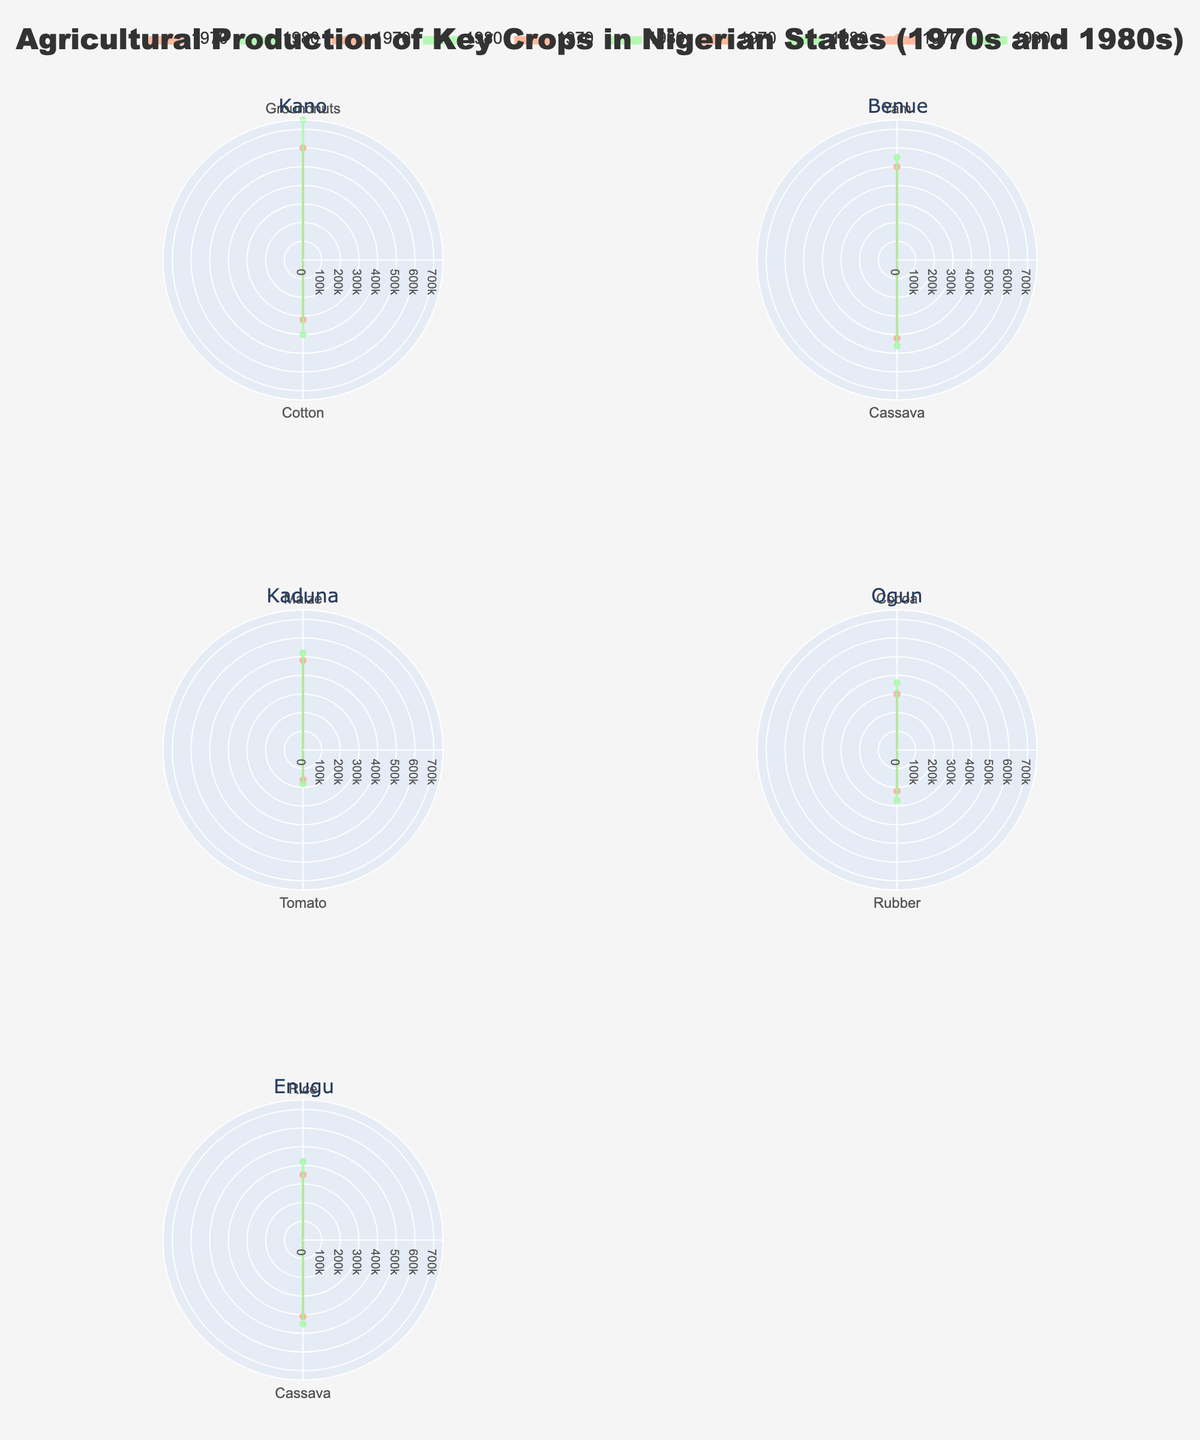How many states are represented in the figure? There are six subplot titles, and each one corresponds to a unique state.
Answer: 6 Which crop had the lowest production in Kano in 1970? In the Kano subplot for 1970, the smallest value on the radial axis corresponds to Cotton with 320,000 metric tons.
Answer: Cotton How did the production of groundnuts in Kano change from 1970 to 1980? In the Kano subplot, the radial value for Groundnuts increased from 600,000 metric tons in 1970 to 750,000 metric tons in 1980.
Answer: Increased Which state had the highest production of Cocoa in the 1980s? Only Ogun produces Cocoa, shown by the largest radial value in its subplot. It increased to 360,000 metric tons in the 1980s.
Answer: Ogun Were there any crops with no change in production between the 1970s and the 1980s? By examining each subplot, we can see that no crops maintained the same radial value between the two time periods; all show changes.
Answer: No Which state's production of Maize was higher in 1980 compared to 1970? In the Kaduna subplot, the production of Maize increased from 480,000 metric tons in 1970 to 520,000 metric tons in 1980.
Answer: Kaduna What is the total production of Yams and Cassava in Benue in 1980? For Benue in 1980, Yam production is 550,000 metric tons and Cassava production is 460,000 metric tons. Adding these values gives 550,000 + 460,000 = 1,010,000 metric tons.
Answer: 1,010,000 metric tons Compare the Tomato production in Kaduna in the 1980s with Cocoa production in Ogun in the 1970s. Which one is higher? In the Kaduna subplot for 1980, Tomato production is 180,000 metric tons while, in the Ogun subplot for 1970, Cocoa production is 300,000 metric tons. Comparing these values, Cocoa in Ogun is higher.
Answer: Cocoa in Ogun Which crop shows the most significant increase in production in the 1980s for any state? By observing all subplots, Groundnuts in Kano shows the most significant increase from 600,000 metric tons in 1970 to 750,000 metric tons in 1980, a difference of 150,000 metric tons.
Answer: Groundnuts in Kano 